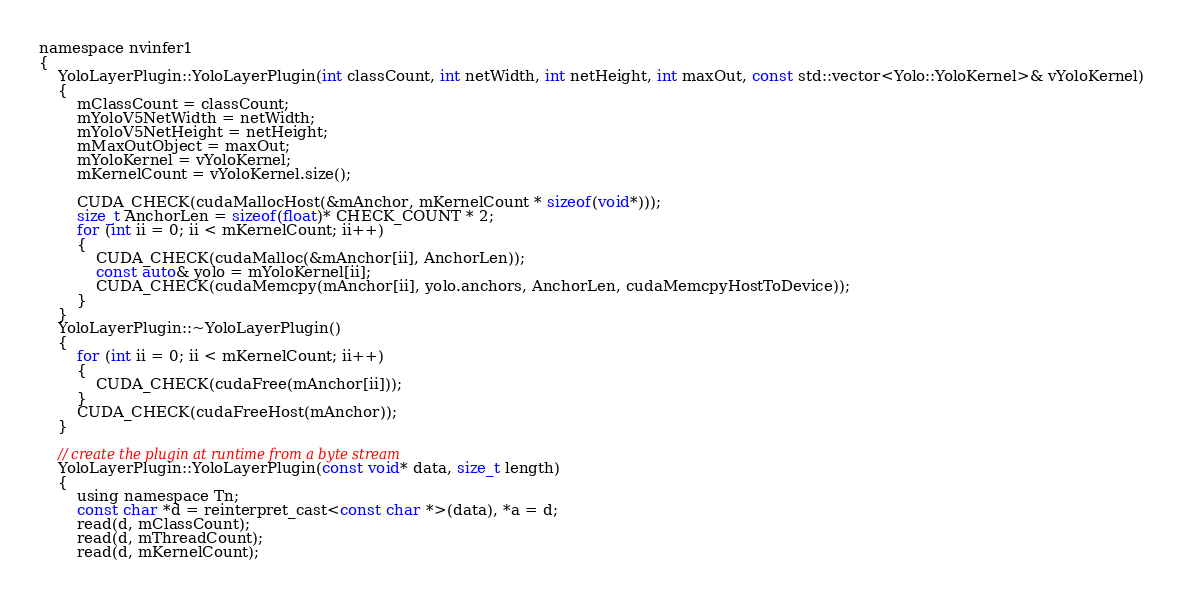<code> <loc_0><loc_0><loc_500><loc_500><_Cuda_>namespace nvinfer1
{
    YoloLayerPlugin::YoloLayerPlugin(int classCount, int netWidth, int netHeight, int maxOut, const std::vector<Yolo::YoloKernel>& vYoloKernel)
    {
        mClassCount = classCount;
        mYoloV5NetWidth = netWidth;
        mYoloV5NetHeight = netHeight;
        mMaxOutObject = maxOut;
        mYoloKernel = vYoloKernel;
        mKernelCount = vYoloKernel.size();

        CUDA_CHECK(cudaMallocHost(&mAnchor, mKernelCount * sizeof(void*)));
        size_t AnchorLen = sizeof(float)* CHECK_COUNT * 2;
        for (int ii = 0; ii < mKernelCount; ii++)
        {
            CUDA_CHECK(cudaMalloc(&mAnchor[ii], AnchorLen));
            const auto& yolo = mYoloKernel[ii];
            CUDA_CHECK(cudaMemcpy(mAnchor[ii], yolo.anchors, AnchorLen, cudaMemcpyHostToDevice));
        }
    }
    YoloLayerPlugin::~YoloLayerPlugin()
    {
        for (int ii = 0; ii < mKernelCount; ii++)
        {
            CUDA_CHECK(cudaFree(mAnchor[ii]));
        }
        CUDA_CHECK(cudaFreeHost(mAnchor));
    }

    // create the plugin at runtime from a byte stream
    YoloLayerPlugin::YoloLayerPlugin(const void* data, size_t length)
    {
        using namespace Tn;
        const char *d = reinterpret_cast<const char *>(data), *a = d;
        read(d, mClassCount);
        read(d, mThreadCount);
        read(d, mKernelCount);</code> 